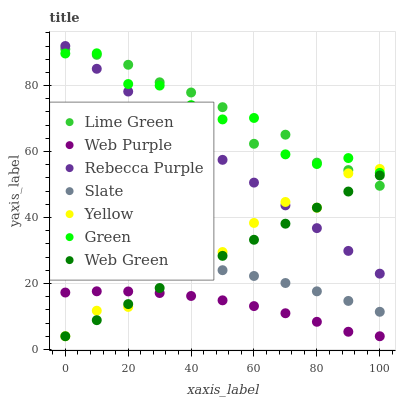Does Web Purple have the minimum area under the curve?
Answer yes or no. Yes. Does Lime Green have the maximum area under the curve?
Answer yes or no. Yes. Does Slate have the minimum area under the curve?
Answer yes or no. No. Does Slate have the maximum area under the curve?
Answer yes or no. No. Is Web Green the smoothest?
Answer yes or no. Yes. Is Yellow the roughest?
Answer yes or no. Yes. Is Slate the smoothest?
Answer yes or no. No. Is Slate the roughest?
Answer yes or no. No. Does Web Green have the lowest value?
Answer yes or no. Yes. Does Slate have the lowest value?
Answer yes or no. No. Does Rebecca Purple have the highest value?
Answer yes or no. Yes. Does Slate have the highest value?
Answer yes or no. No. Is Web Purple less than Lime Green?
Answer yes or no. Yes. Is Green greater than Slate?
Answer yes or no. Yes. Does Green intersect Yellow?
Answer yes or no. Yes. Is Green less than Yellow?
Answer yes or no. No. Is Green greater than Yellow?
Answer yes or no. No. Does Web Purple intersect Lime Green?
Answer yes or no. No. 